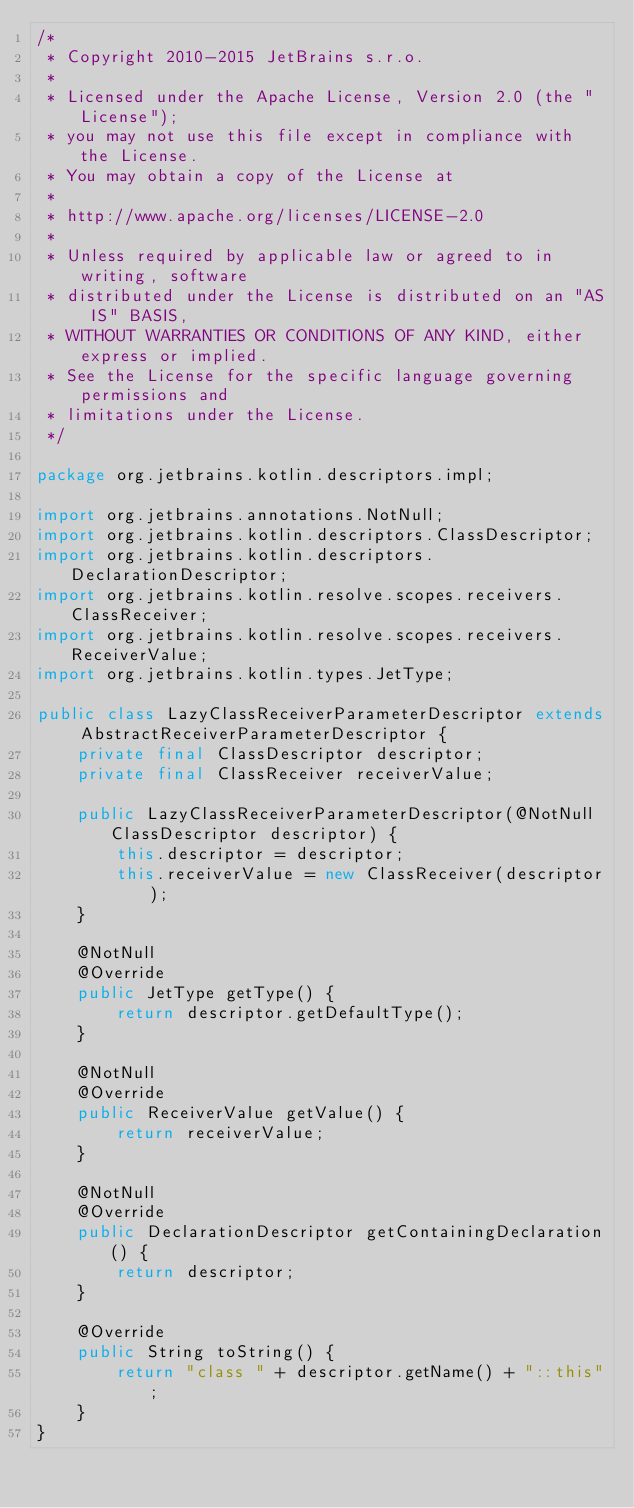<code> <loc_0><loc_0><loc_500><loc_500><_Java_>/*
 * Copyright 2010-2015 JetBrains s.r.o.
 *
 * Licensed under the Apache License, Version 2.0 (the "License");
 * you may not use this file except in compliance with the License.
 * You may obtain a copy of the License at
 *
 * http://www.apache.org/licenses/LICENSE-2.0
 *
 * Unless required by applicable law or agreed to in writing, software
 * distributed under the License is distributed on an "AS IS" BASIS,
 * WITHOUT WARRANTIES OR CONDITIONS OF ANY KIND, either express or implied.
 * See the License for the specific language governing permissions and
 * limitations under the License.
 */

package org.jetbrains.kotlin.descriptors.impl;

import org.jetbrains.annotations.NotNull;
import org.jetbrains.kotlin.descriptors.ClassDescriptor;
import org.jetbrains.kotlin.descriptors.DeclarationDescriptor;
import org.jetbrains.kotlin.resolve.scopes.receivers.ClassReceiver;
import org.jetbrains.kotlin.resolve.scopes.receivers.ReceiverValue;
import org.jetbrains.kotlin.types.JetType;

public class LazyClassReceiverParameterDescriptor extends AbstractReceiverParameterDescriptor {
    private final ClassDescriptor descriptor;
    private final ClassReceiver receiverValue;

    public LazyClassReceiverParameterDescriptor(@NotNull ClassDescriptor descriptor) {
        this.descriptor = descriptor;
        this.receiverValue = new ClassReceiver(descriptor);
    }

    @NotNull
    @Override
    public JetType getType() {
        return descriptor.getDefaultType();
    }

    @NotNull
    @Override
    public ReceiverValue getValue() {
        return receiverValue;
    }

    @NotNull
    @Override
    public DeclarationDescriptor getContainingDeclaration() {
        return descriptor;
    }

    @Override
    public String toString() {
        return "class " + descriptor.getName() + "::this";
    }
}
</code> 